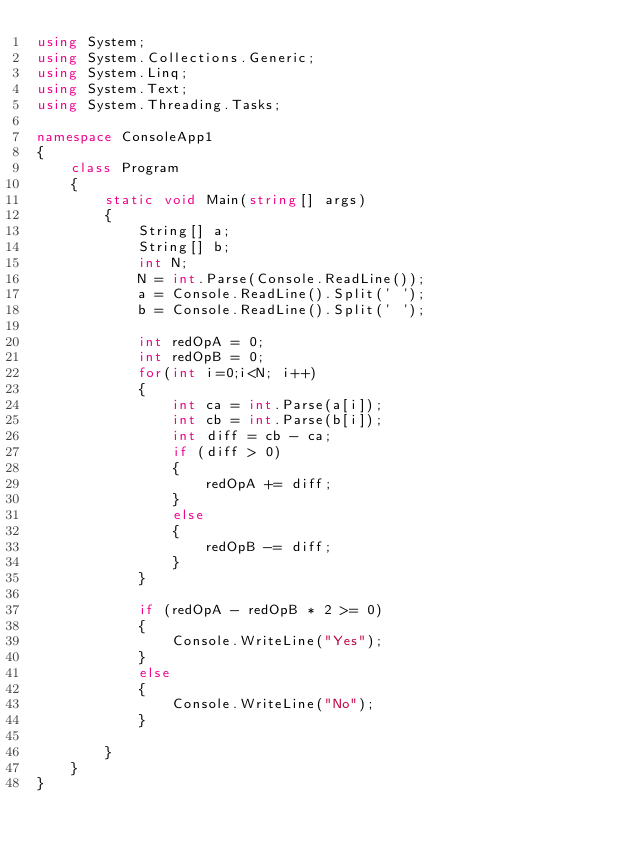Convert code to text. <code><loc_0><loc_0><loc_500><loc_500><_C#_>using System;
using System.Collections.Generic;
using System.Linq;
using System.Text;
using System.Threading.Tasks;

namespace ConsoleApp1
{
    class Program
    {
        static void Main(string[] args)
        {
            String[] a;
            String[] b;
            int N;
            N = int.Parse(Console.ReadLine());
            a = Console.ReadLine().Split(' ');
            b = Console.ReadLine().Split(' ');

            int redOpA = 0;
            int redOpB = 0;
            for(int i=0;i<N; i++)
            {
                int ca = int.Parse(a[i]);
                int cb = int.Parse(b[i]);
                int diff = cb - ca;
                if (diff > 0)
                {
                    redOpA += diff;
                }
                else
                {
                    redOpB -= diff;
                }
            }

            if (redOpA - redOpB * 2 >= 0)
            {
                Console.WriteLine("Yes");
            }
            else
            {
                Console.WriteLine("No");
            }

        }
    }
}
</code> 